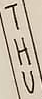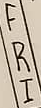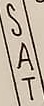Transcribe the words shown in these images in order, separated by a semicolon. THU; FRI; SAT 